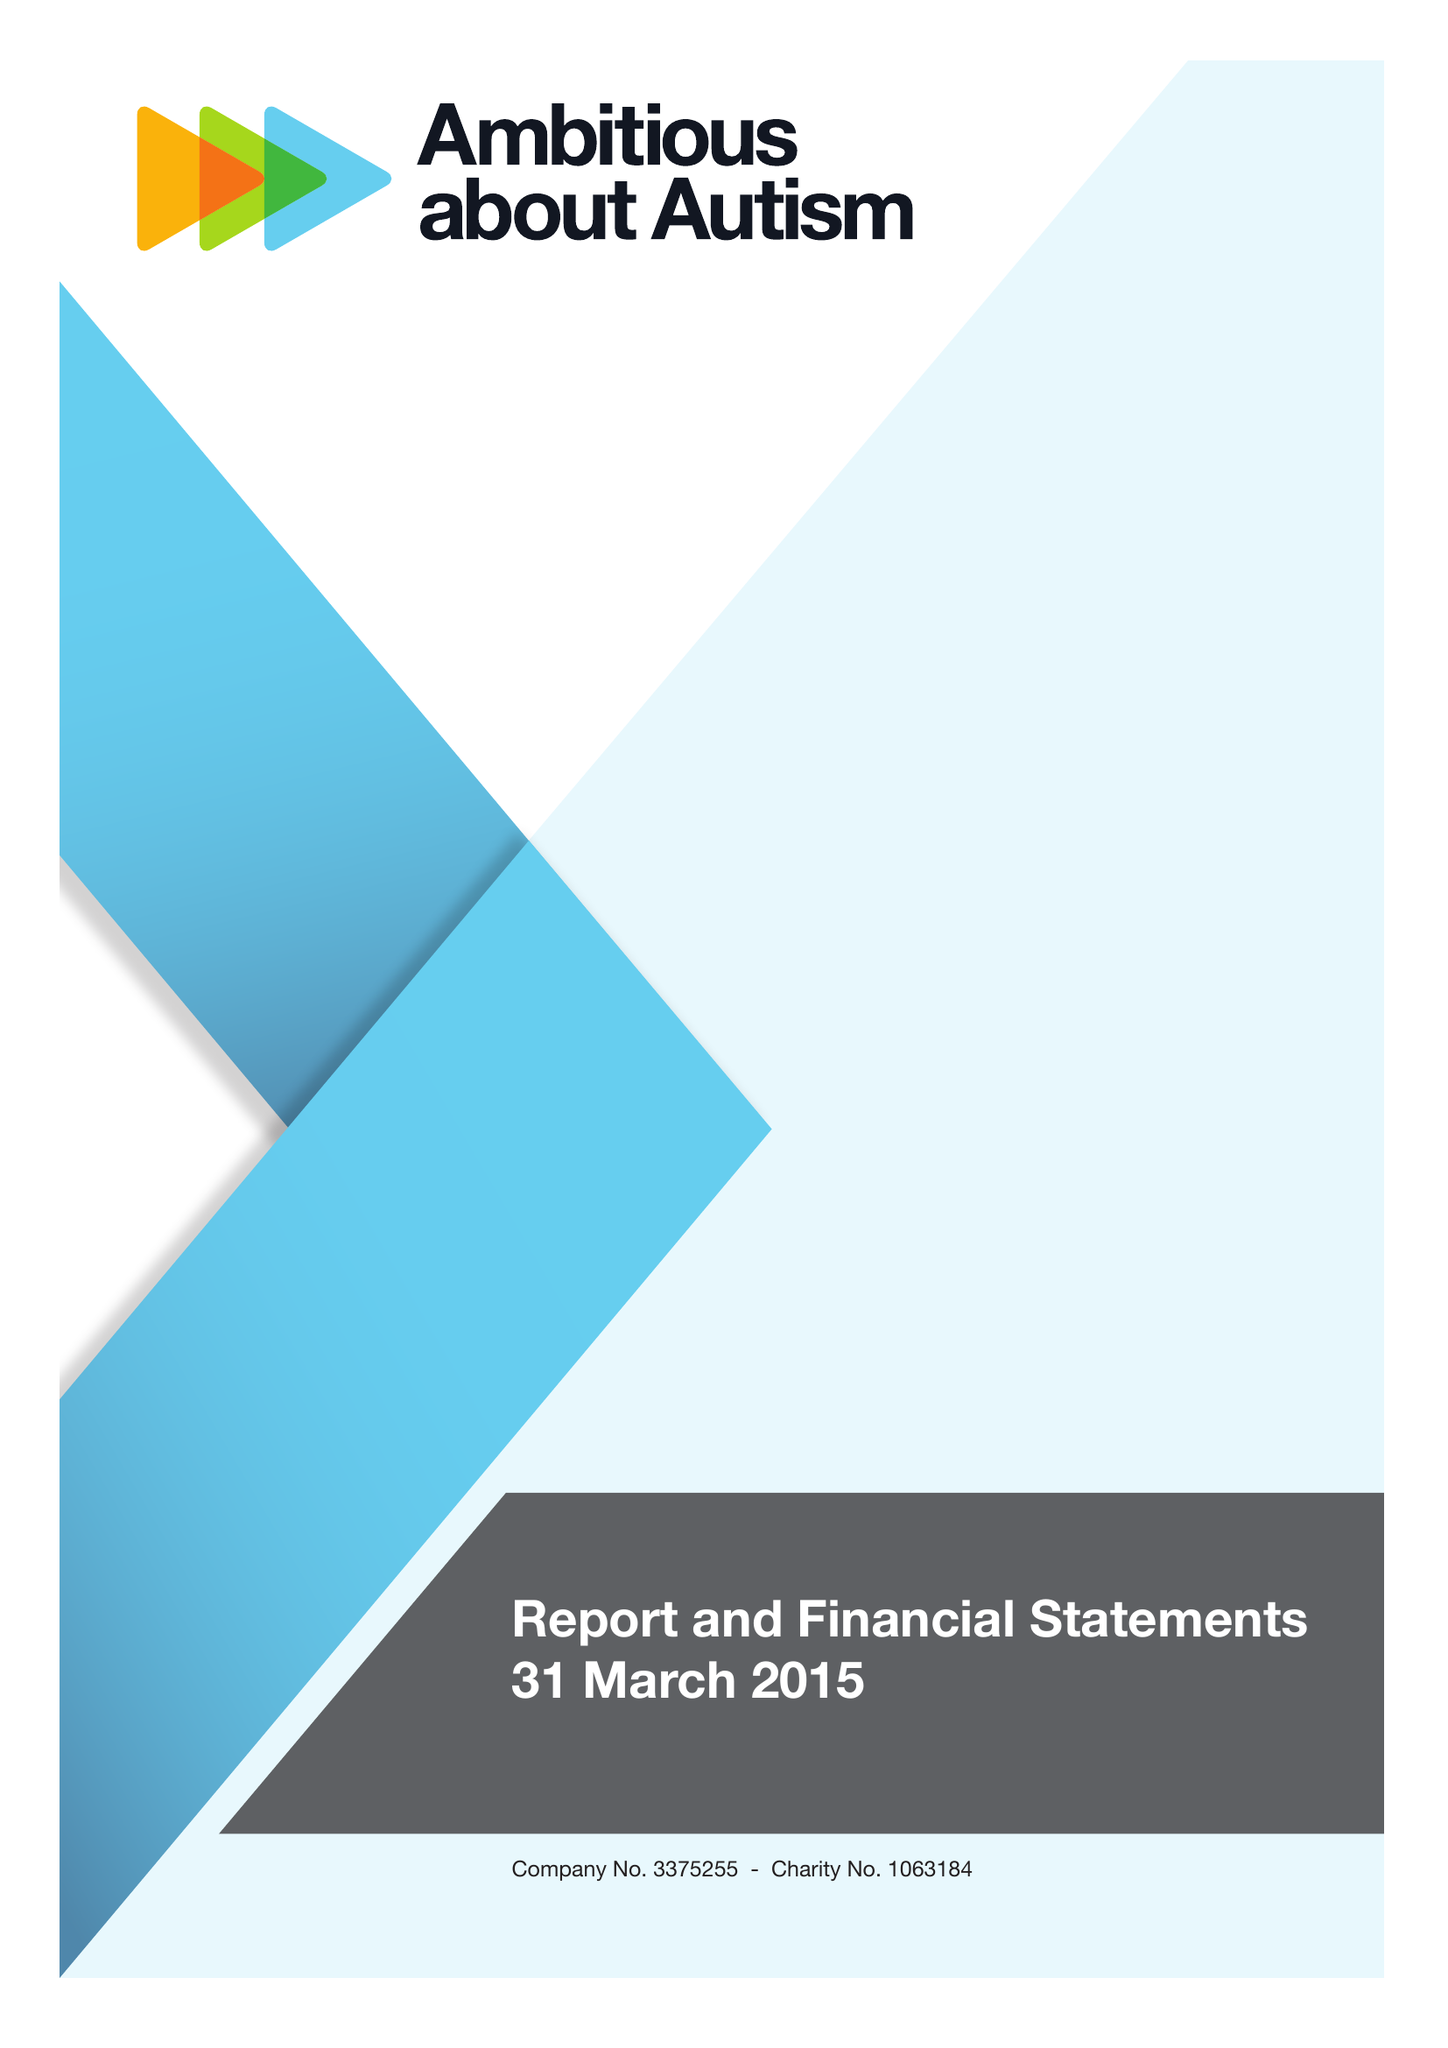What is the value for the address__street_line?
Answer the question using a single word or phrase. WOODSIDE AVENUE 